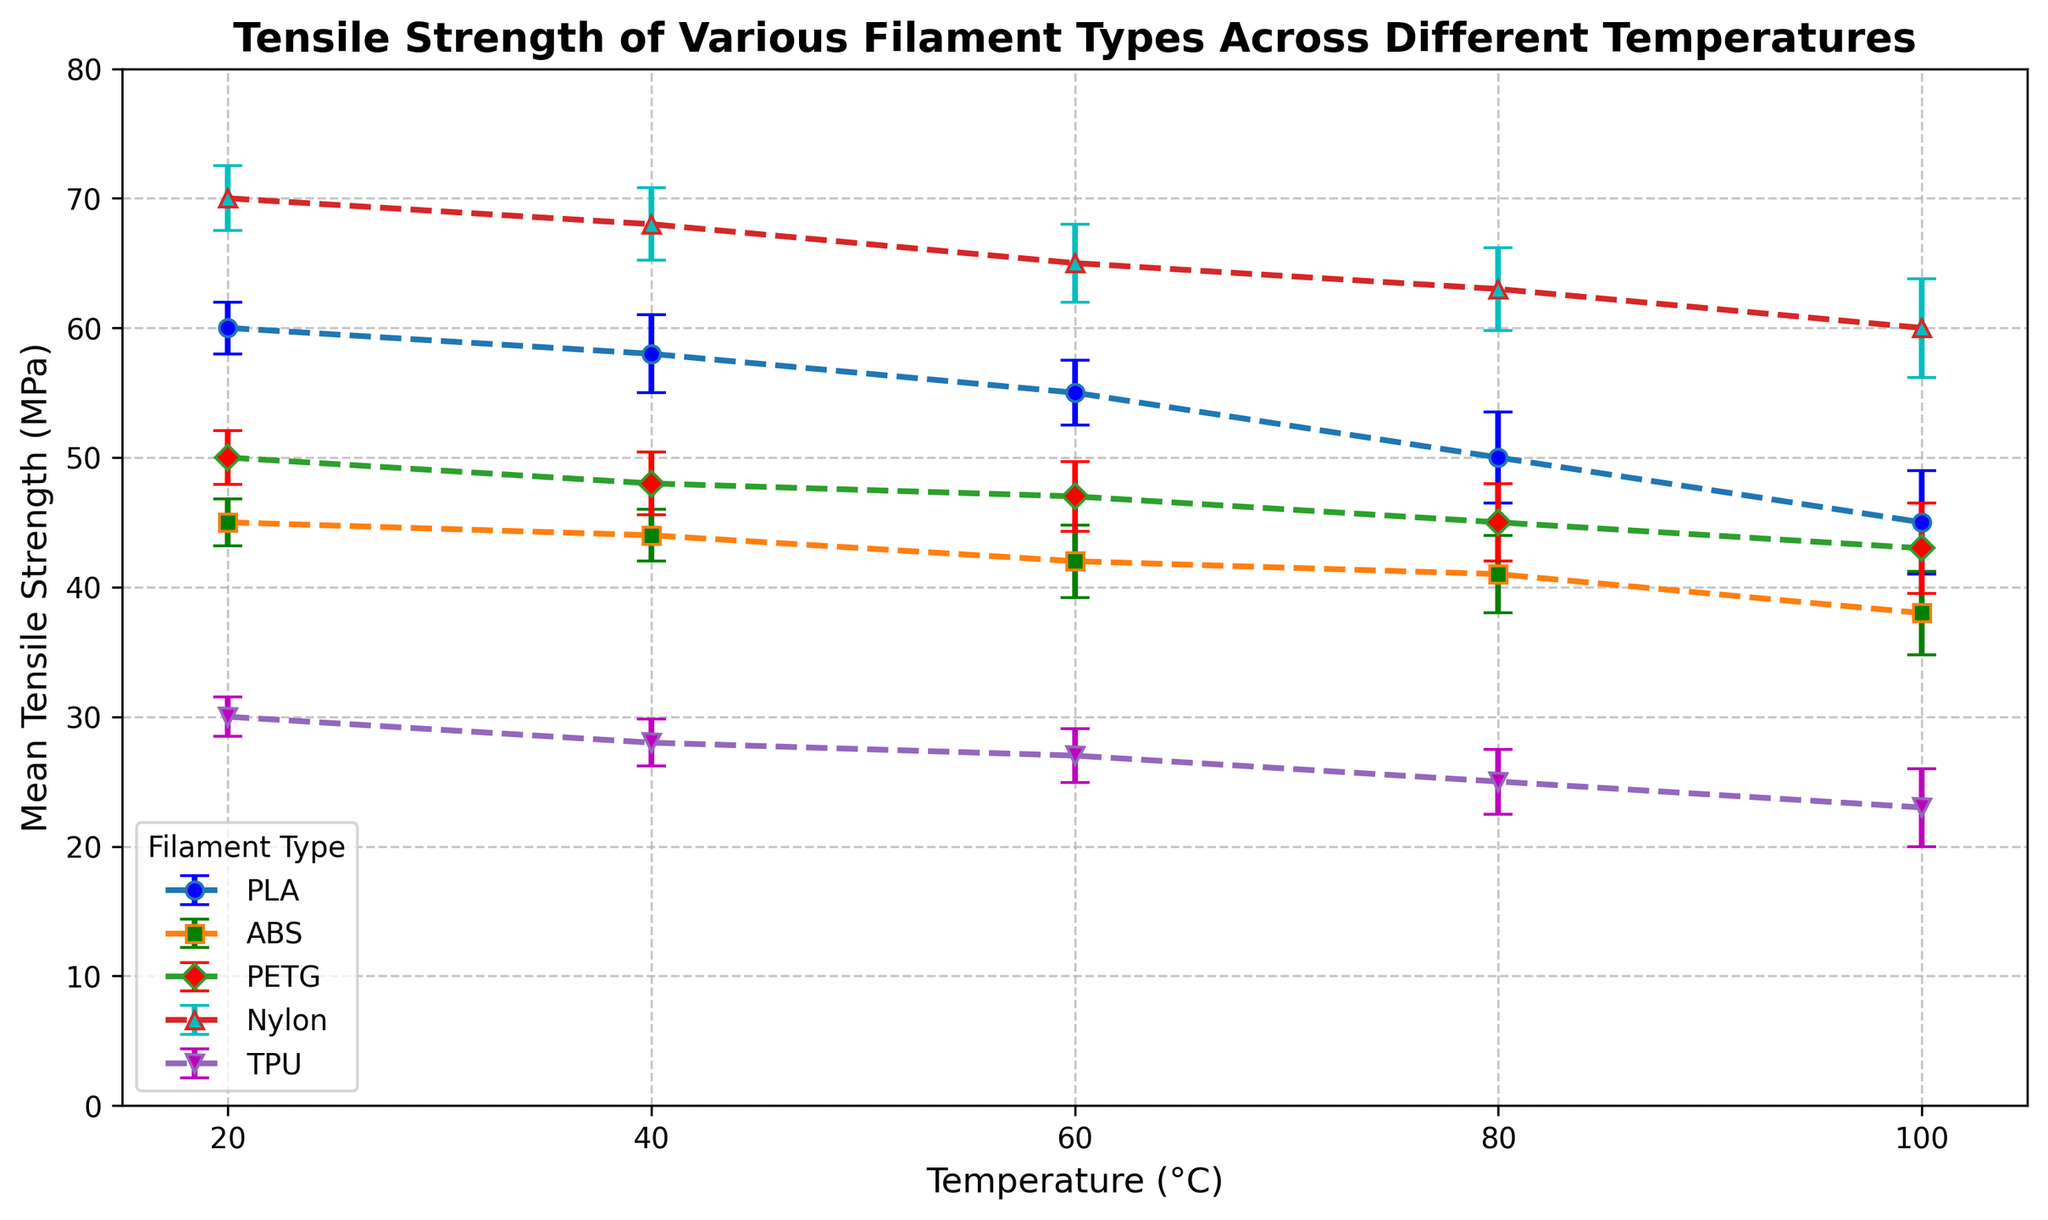What is the tensile strength of PLA at 60°C? The chart shows error bars representing the mean tensile strength and standard deviation for each filament type at different temperatures. For PLA at 60°C, the mean tensile strength is shown as 55 MPa.
Answer: 55 MPa Which filament has the highest mean tensile strength at 20°C? To determine this, you need to compare the mean tensile strengths of all filaments at 20°C. Nylon has the highest mean tensile strength at 20°C, which is 70 MPa.
Answer: Nylon How does the mean tensile strength of ABS change from 20°C to 100°C? You need to look at the mean tensile strengths of ABS at 20°C and 100°C and calculate the difference. At 20°C, the mean tensile strength is 45 MPa, and at 100°C, it is 38 MPa. The change is 45 - 38 = 7 MPa decrease.
Answer: Decreases by 7 MPa Which filament type shows the smallest change in mean tensile strength from 20°C to 100°C? You examine the change in mean tensile strength for each filament from 20°C to 100°C. PLA changes by 60-45=15 MPa, ABS by 45-38=7 MPa, PETG by 50-43=7 MPa, Nylon by 70-60=10 MPa, and TPU by 30-23=7 MPa. The smallest change is 7 MPa, observed in ABS, PETG, and TPU.
Answer: ABS, PETG, TPU What is the mean tensile strength of TPU at 40°C and 80°C combined? You add the mean tensile strengths of TPU at 40°C and 80°C: 28 MPa at 40°C and 25 MPa at 80°C. So, the combined mean tensile strength is 28 + 25 = 53 MPa.
Answer: 53 MPa Which filament type has the largest standard deviation in tensile strength at 100°C? You need to compare the standard deviations of each filament type at 100°C. PLA has 4 MPa, ABS has 3.2 MPa, PETG has 3.5 MPa, Nylon has 3.8 MPa, and TPU has 3.0 MPa. PLA has the largest standard deviation at 100°C, which is 4 MPa.
Answer: PLA What is the average mean tensile strength of PETG and ABS at 60°C? To find the average mean tensile strength of PETG and ABS at 60°C, you add their mean tensile strengths and divide by 2. PETG has 47 MPa, and ABS has 42 MPa. The average is (47 + 42) / 2 = 44.5 MPa.
Answer: 44.5 MPa Between PLA and Nylon, which filament shows a greater decrease in mean tensile strength from 20°C to 60°C? Calculate the decrease for each filament: PLA’s decrease is 60 - 55 = 5 MPa, and Nylon’s decrease is 70 - 65 = 5 MPa. Both show the same decrease.
Answer: Both show the same decrease 